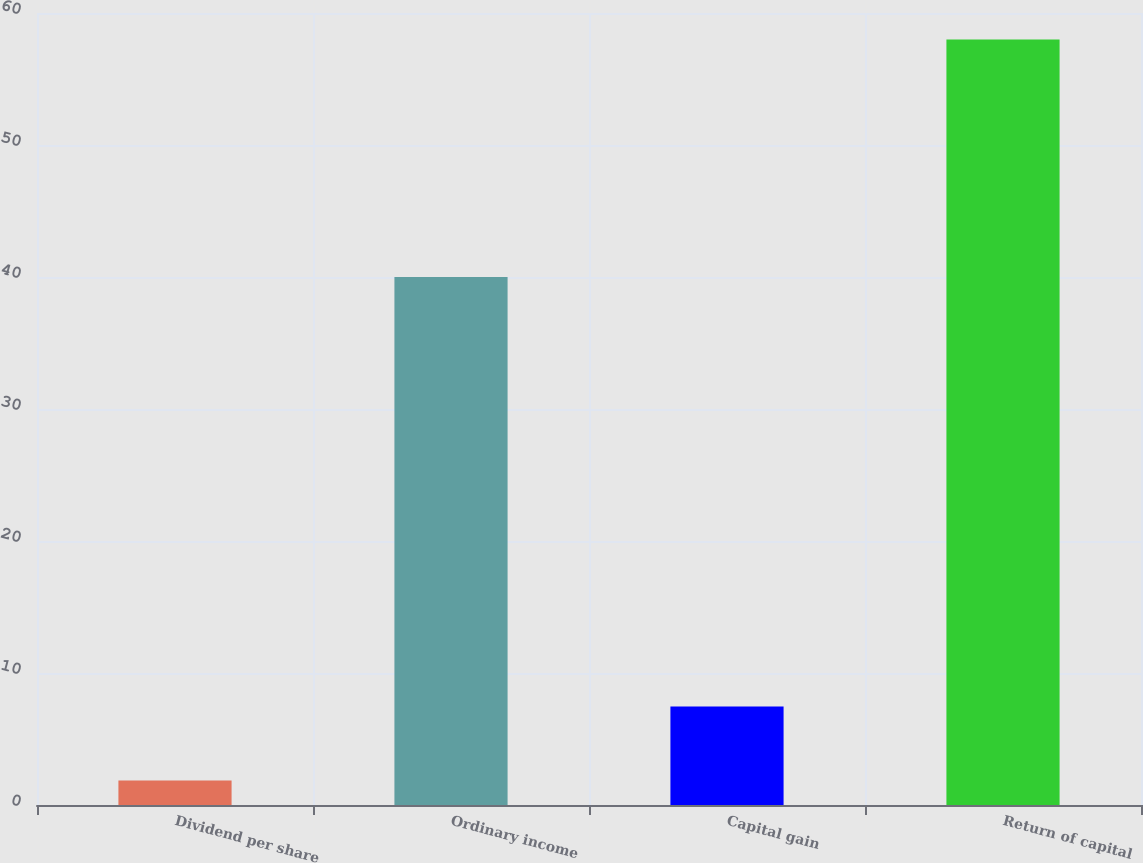Convert chart. <chart><loc_0><loc_0><loc_500><loc_500><bar_chart><fcel>Dividend per share<fcel>Ordinary income<fcel>Capital gain<fcel>Return of capital<nl><fcel>1.85<fcel>40<fcel>7.46<fcel>58<nl></chart> 